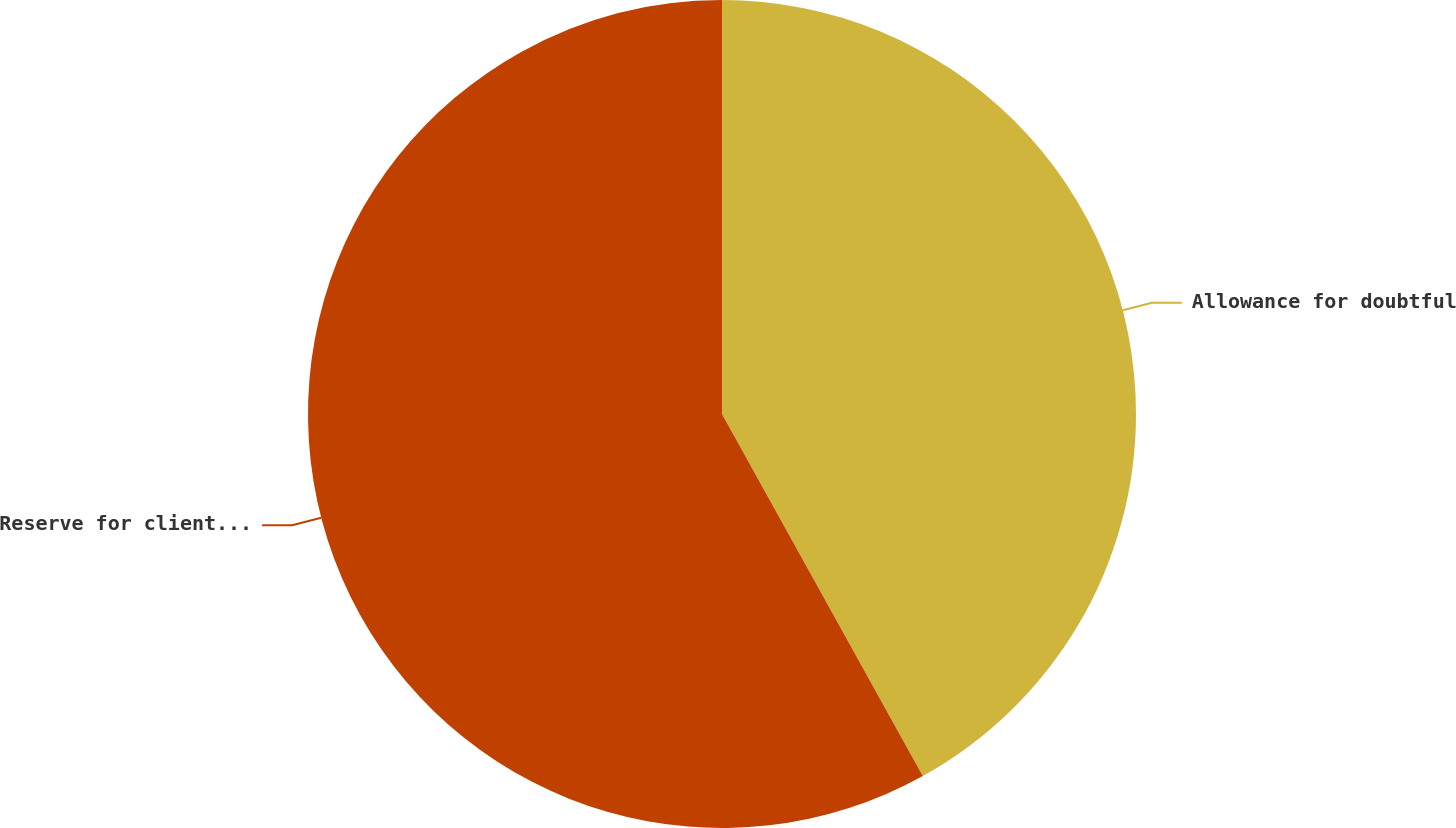<chart> <loc_0><loc_0><loc_500><loc_500><pie_chart><fcel>Allowance for doubtful<fcel>Reserve for client fund losses<nl><fcel>41.94%<fcel>58.06%<nl></chart> 